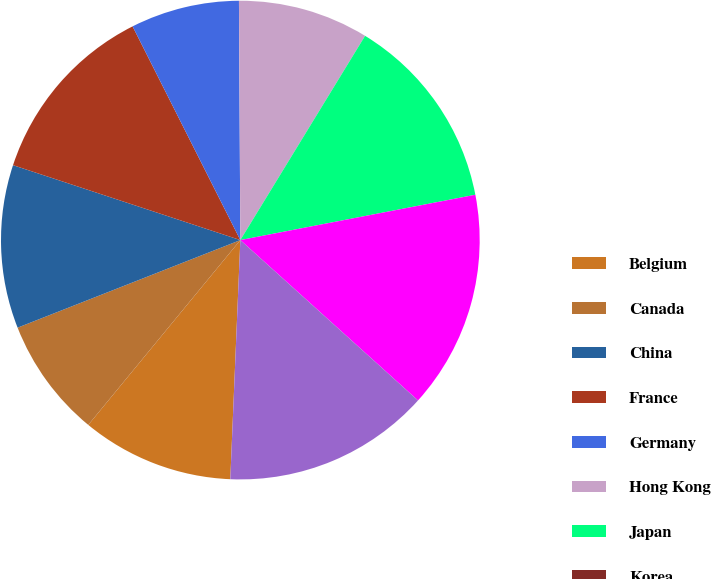<chart> <loc_0><loc_0><loc_500><loc_500><pie_chart><fcel>Belgium<fcel>Canada<fcel>China<fcel>France<fcel>Germany<fcel>Hong Kong<fcel>Japan<fcel>Korea<fcel>Russia<fcel>Spain<nl><fcel>10.29%<fcel>8.08%<fcel>11.03%<fcel>12.5%<fcel>7.34%<fcel>8.82%<fcel>13.24%<fcel>0.0%<fcel>14.72%<fcel>13.98%<nl></chart> 